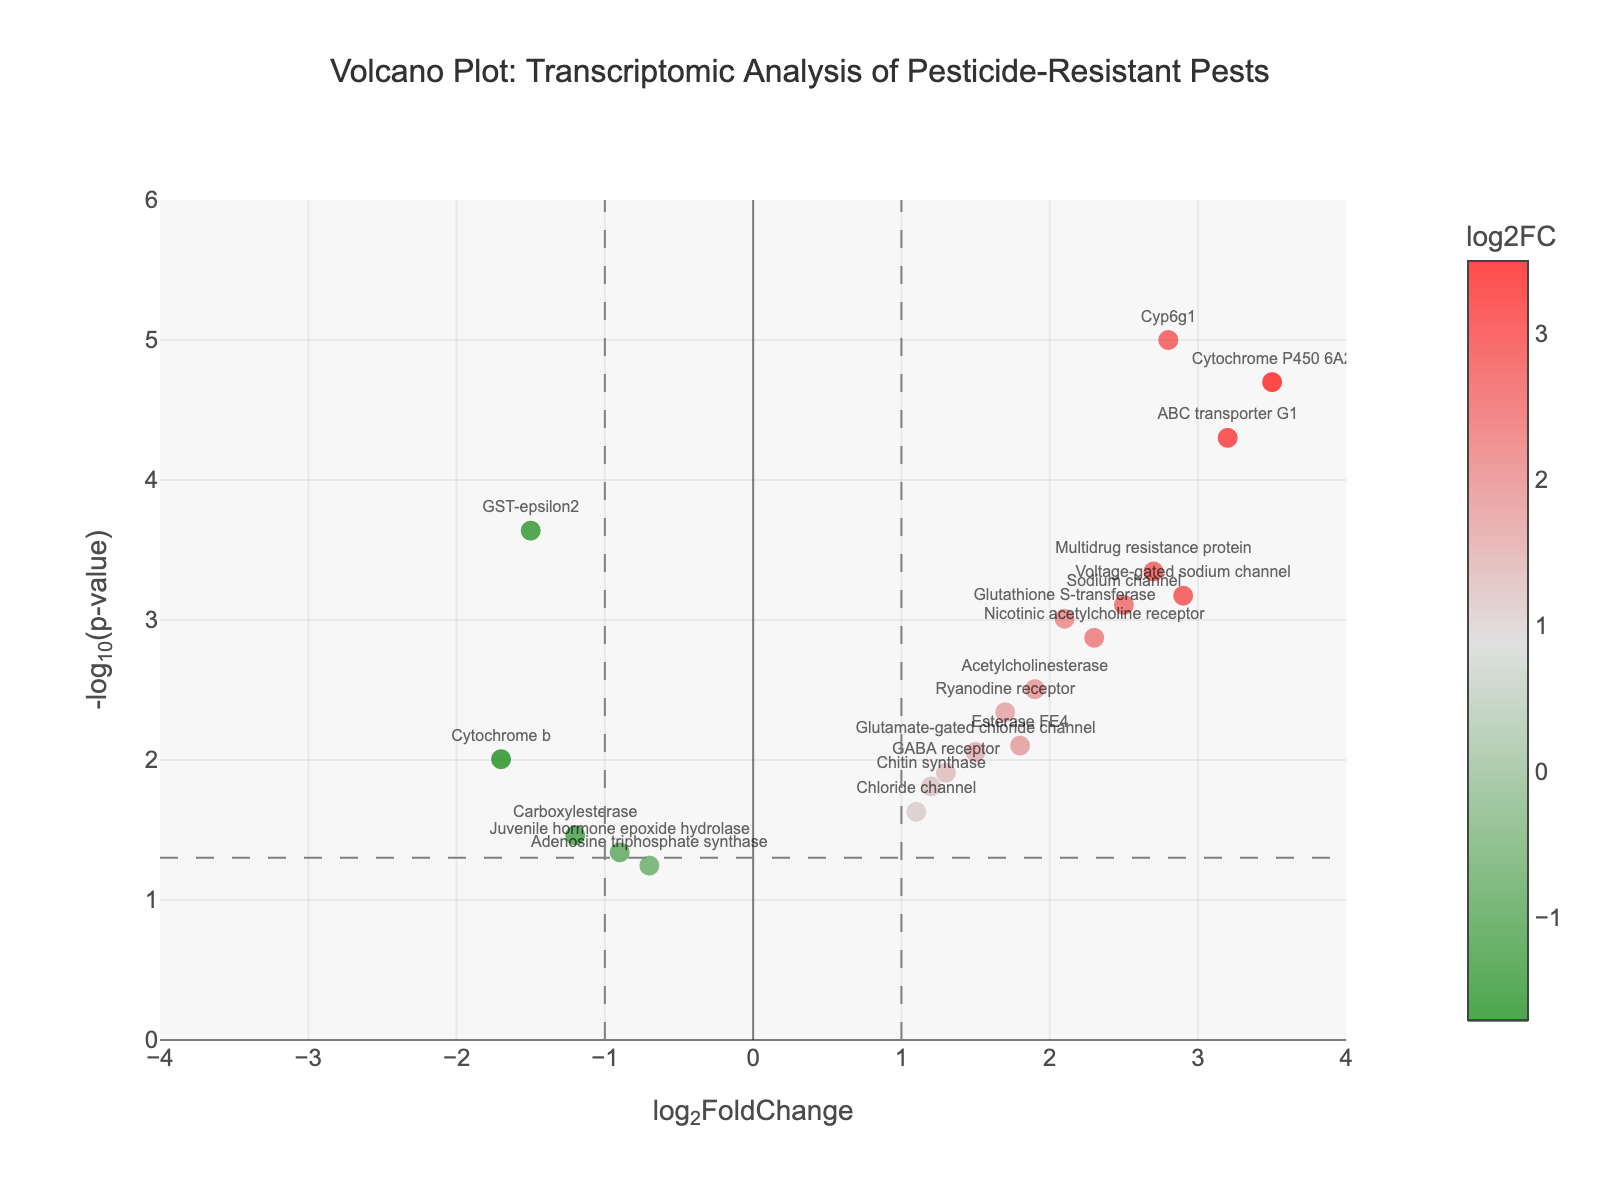What is the title of the figure? The title is usually presented at the top of the figure. By looking there, we can see the string inside the title property.
Answer: Volcano Plot: Transcriptomic Analysis of Pesticide-Resistant Pests What do the x-axis and y-axis represent in this plot? By examining the labels along the x-axis and y-axis, we can understand what they represent. The x-axis has log2FoldChange, and the y-axis has -log10(p-value).
Answer: The x-axis represents log2FoldChange, and the y-axis represents -log10(p-value) How many genes have a significant p-value (p < 0.05)? Significant p-values correspond to points above the horizontal dashed line at -log10(p-value) of about 1.3. We count the points above this threshold.
Answer: 14 Which gene has the highest log2FoldChange? By locating the point farthest to the right on the x-axis, we can identify the gene with the highest log2FoldChange.
Answer: Cytochrome P450 6A2 How many genes are down-regulated with a significant p-value (p < 0.05)? Down-regulated genes have a negative log2FoldChange and a significant p-value if they are above the grey horizontal dashed line. We count such points.
Answer: 2 Which gene combines to have the greatest log2FoldChange and p-value? We need to assess both log2FoldChange and p-value to find a gene that is far right (high log2FoldChange) and far up (low p-value).
Answer: Cytochrome P450 6A2 Identify the gene with the -log10(p-value) closest to 3 and provide its log2FoldChange. By locating the point closest to y=3 and examining its x-coordinate, we reveal the gene and its log2FoldChange.
Answer: ABC transporter G1, 3.2 Which gene has the lowest -log10(p-value) but still significant? From the significant points (above y=1.3), find the point closest to this threshold.
Answer: Carboxylesterase What colors indicate up-regulated and down-regulated genes? By examining the color scale bar, we see red is for up-regulated (positive log2FoldChange), and green is for down-regulated (negative log2FoldChange).
Answer: Red and green How many genes have a log2FoldChange greater than 2 and a significant p-value (p < 0.05)? By identifying points to the right of x=2 and above y=1.3 (significant), we count the occurrences.
Answer: 8 